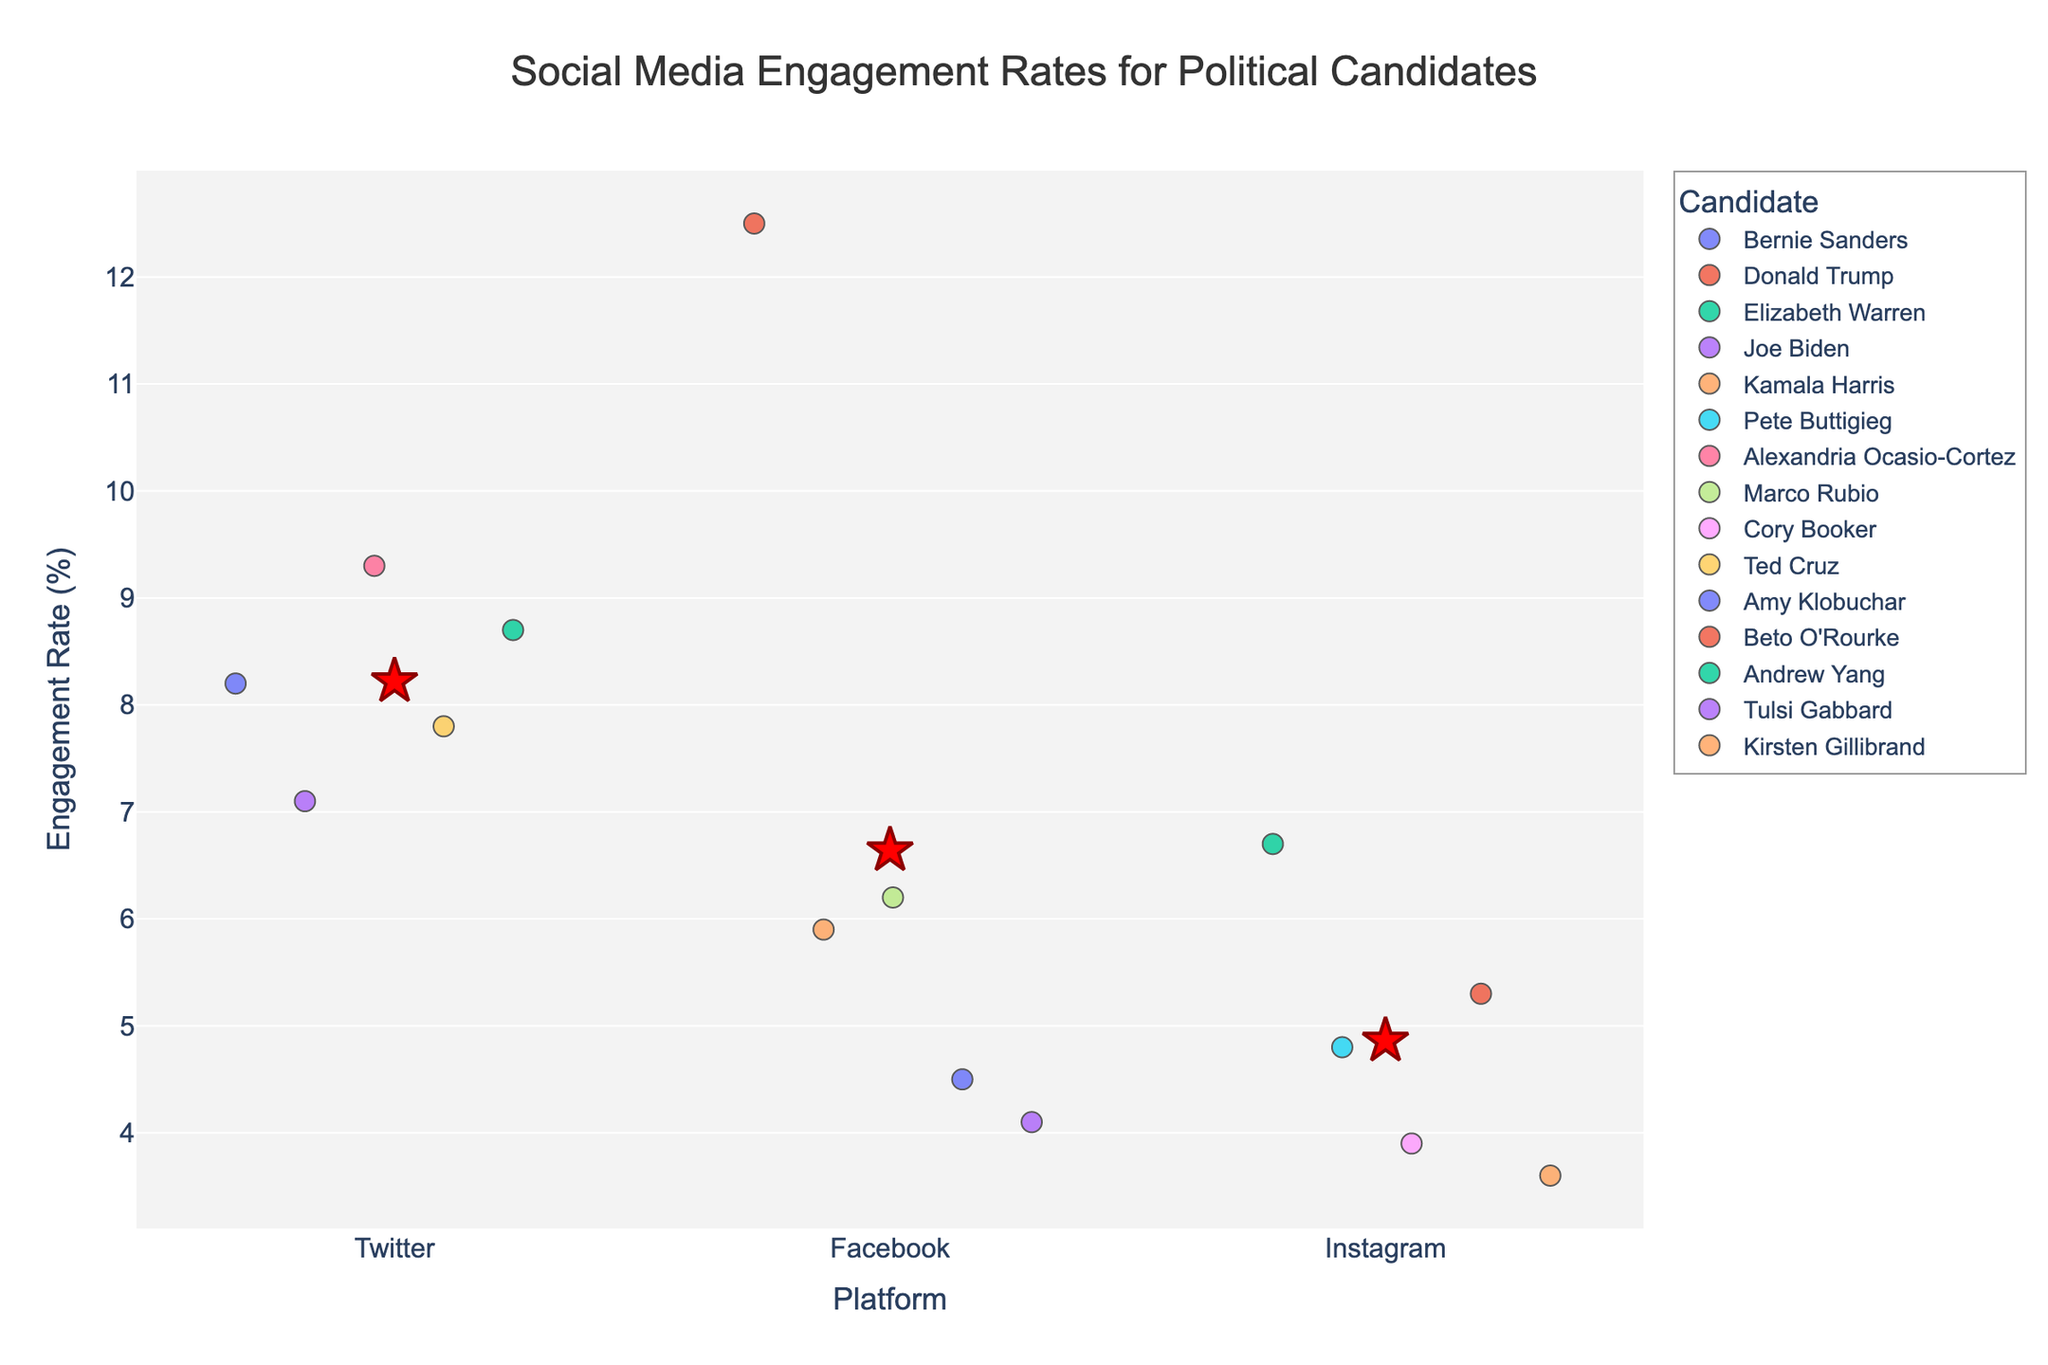What is the title of the figure? The title of the figure is displayed at the top of the plot. It reads "Social Media Engagement Rates for Political Candidates."
Answer: Social Media Engagement Rates for Political Candidates How many platforms are displayed in the figure? The x-axis shows the categories for platforms. The unique platforms displayed are Twitter, Facebook, and Instagram.
Answer: 3 Which candidate has the highest engagement rate on Facebook? By examining the data points on the Facebook category of the x-axis, the candidate with the highest y-value (Engagement Rate) is Donald Trump.
Answer: Donald Trump What's the mean engagement rate for the Instagram platform? Locate the star symbol on the Instagram category and find the y-value it corresponds to.
Answer: 4.8667 Which platform shows the lowest average engagement rate? Observe the star symbols representing the mean engagement rates on all three platforms. The star with the lowest y-value corresponds to the platform Instagram.
Answer: Instagram How do Elizabeth Warren's engagement rates on Instagram compare to those of Pete Buttigieg? Look at the y-values of the data points in the Instagram category for Elizabeth Warren and Pete Buttigieg respectively. Elizabeth Warren's engagement rate (6.7) is higher than Pete Buttigieg's (4.8).
Answer: Elizabeth Warren's is higher Identify the two candidates with the highest engagement rates on Twitter? Examine the y-values of data points within the Twitter category; Bernie Sanders (8.2) and Alexandria Ocasio-Cortez (9.3) have the highest rates.
Answer: Alexandria Ocasio-Cortez and Andrew Yang On which platform does the candidate with the highest overall engagement rate post? Identify the highest y-value across all platforms; Donald Trump on Facebook has the highest at 12.5.
Answer: Facebook What is the main visual element used to represent the candidates' engagement rates? The main visual elements are colored dots plotted on a strip plot, each representing an individual candidate's engagement rate.
Answer: Colored dots 